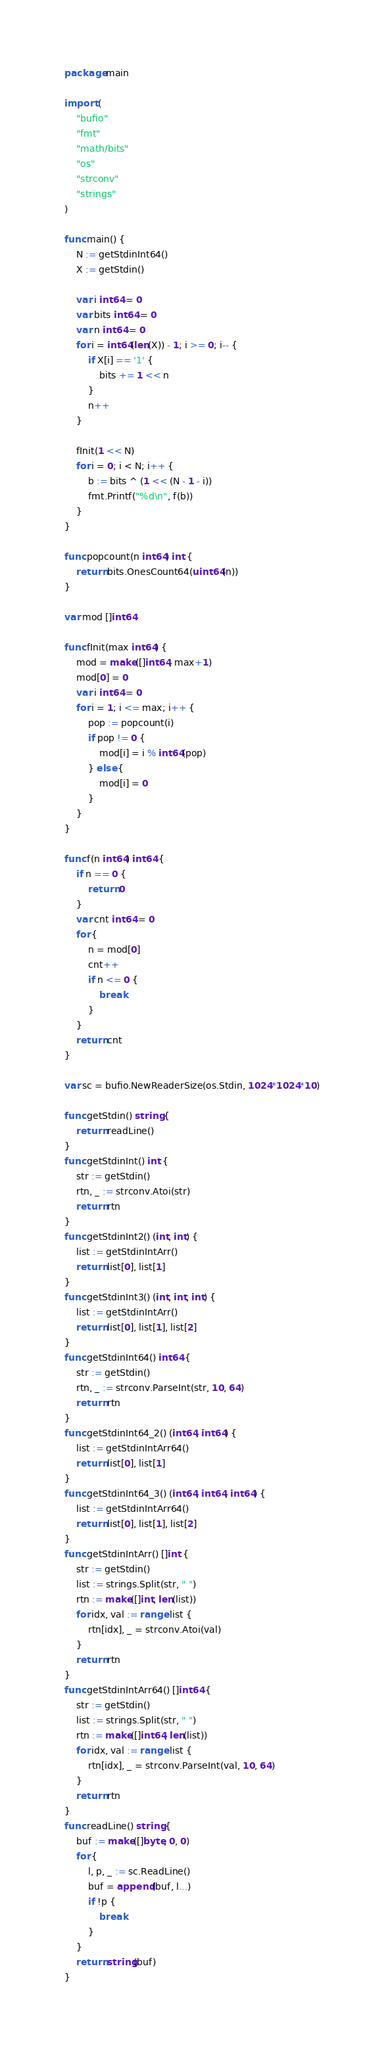Convert code to text. <code><loc_0><loc_0><loc_500><loc_500><_Go_>package main

import (
	"bufio"
	"fmt"
	"math/bits"
	"os"
	"strconv"
	"strings"
)

func main() {
	N := getStdinInt64()
	X := getStdin()

	var i int64 = 0
	var bits int64 = 0
	var n int64 = 0
	for i = int64(len(X)) - 1; i >= 0; i-- {
		if X[i] == '1' {
			bits += 1 << n
		}
		n++
	}

	fInit(1 << N)
	for i = 0; i < N; i++ {
		b := bits ^ (1 << (N - 1 - i))
		fmt.Printf("%d\n", f(b))
	}
}

func popcount(n int64) int {
	return bits.OnesCount64(uint64(n))
}

var mod []int64

func fInit(max int64) {
	mod = make([]int64, max+1)
	mod[0] = 0
	var i int64 = 0
	for i = 1; i <= max; i++ {
		pop := popcount(i)
		if pop != 0 {
			mod[i] = i % int64(pop)
		} else {
			mod[i] = 0
		}
	}
}

func f(n int64) int64 {
	if n == 0 {
		return 0
	}
	var cnt int64 = 0
	for {
		n = mod[0]
		cnt++
		if n <= 0 {
			break
		}
	}
	return cnt
}

var sc = bufio.NewReaderSize(os.Stdin, 1024*1024*10)

func getStdin() string {
	return readLine()
}
func getStdinInt() int {
	str := getStdin()
	rtn, _ := strconv.Atoi(str)
	return rtn
}
func getStdinInt2() (int, int) {
	list := getStdinIntArr()
	return list[0], list[1]
}
func getStdinInt3() (int, int, int) {
	list := getStdinIntArr()
	return list[0], list[1], list[2]
}
func getStdinInt64() int64 {
	str := getStdin()
	rtn, _ := strconv.ParseInt(str, 10, 64)
	return rtn
}
func getStdinInt64_2() (int64, int64) {
	list := getStdinIntArr64()
	return list[0], list[1]
}
func getStdinInt64_3() (int64, int64, int64) {
	list := getStdinIntArr64()
	return list[0], list[1], list[2]
}
func getStdinIntArr() []int {
	str := getStdin()
	list := strings.Split(str, " ")
	rtn := make([]int, len(list))
	for idx, val := range list {
		rtn[idx], _ = strconv.Atoi(val)
	}
	return rtn
}
func getStdinIntArr64() []int64 {
	str := getStdin()
	list := strings.Split(str, " ")
	rtn := make([]int64, len(list))
	for idx, val := range list {
		rtn[idx], _ = strconv.ParseInt(val, 10, 64)
	}
	return rtn
}
func readLine() string {
	buf := make([]byte, 0, 0)
	for {
		l, p, _ := sc.ReadLine()
		buf = append(buf, l...)
		if !p {
			break
		}
	}
	return string(buf)
}
</code> 